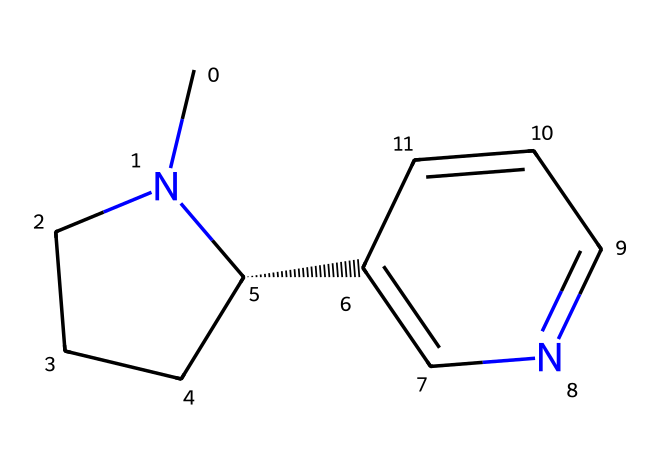What is the molecular formula of nicotine? To find the molecular formula, we can count the atoms of each element in the SMILES representation. In this structure, there are 10 carbon (C) atoms, 14 hydrogen (H) atoms, and 2 nitrogen (N) atoms. Therefore, the molecular formula is C10H14N2.
Answer: C10H14N2 How many rings are present in the nicotine molecule? By analyzing the structure from the SMILES code, we can identify the cyclic parts of the molecule. There are two distinct cyclic structures indicated by the notation in the SMILES, which represent two rings.
Answer: 2 What type of chemical is nicotine classified as? Given that nicotine has nitrogen atoms, it is classified as an alkaloid, which are naturally occurring compounds containing basic nitrogen atoms. Similar organic compounds containing nitrogen also fall under this category.
Answer: alkaloid Does nicotine contain any functional groups? In the nicotine structure, the presence of a nitrogen atom implies the existence of a functional group, specifically a pyridine ring, which is characteristic of alkaloids. Hence, nicotine does contain functional groups, primarily nitrogen-containing.
Answer: yes What is the total number of nitrogen atoms in nicotine? The SMILES representation clearly indicates the presence of two nitrogen (N) atoms in the structure of nicotine. This can be directly counted from the SMILES notation.
Answer: 2 Is nicotine a polar or non-polar molecule? Considering nicotine has polar bonds due to the presence of nitrogen and its structure, which tends to favor a more complex arrangement of polar characteristics, nicotine is generally classified as a polar molecule, which allows for solubility in polar solvents.
Answer: polar 